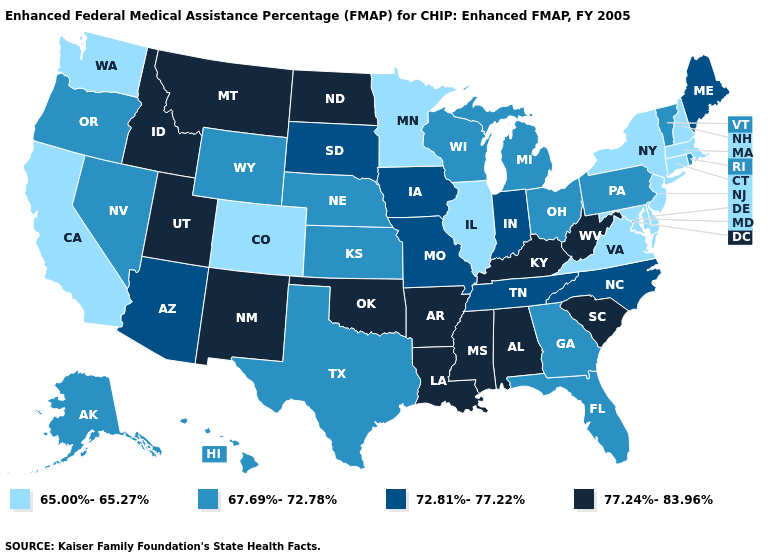Does the map have missing data?
Write a very short answer. No. What is the lowest value in the Northeast?
Short answer required. 65.00%-65.27%. Name the states that have a value in the range 65.00%-65.27%?
Short answer required. California, Colorado, Connecticut, Delaware, Illinois, Maryland, Massachusetts, Minnesota, New Hampshire, New Jersey, New York, Virginia, Washington. Name the states that have a value in the range 65.00%-65.27%?
Concise answer only. California, Colorado, Connecticut, Delaware, Illinois, Maryland, Massachusetts, Minnesota, New Hampshire, New Jersey, New York, Virginia, Washington. Does Michigan have a higher value than North Carolina?
Quick response, please. No. What is the value of Tennessee?
Answer briefly. 72.81%-77.22%. What is the highest value in the USA?
Be succinct. 77.24%-83.96%. Which states hav the highest value in the West?
Answer briefly. Idaho, Montana, New Mexico, Utah. What is the value of Massachusetts?
Short answer required. 65.00%-65.27%. Name the states that have a value in the range 77.24%-83.96%?
Quick response, please. Alabama, Arkansas, Idaho, Kentucky, Louisiana, Mississippi, Montana, New Mexico, North Dakota, Oklahoma, South Carolina, Utah, West Virginia. Name the states that have a value in the range 67.69%-72.78%?
Answer briefly. Alaska, Florida, Georgia, Hawaii, Kansas, Michigan, Nebraska, Nevada, Ohio, Oregon, Pennsylvania, Rhode Island, Texas, Vermont, Wisconsin, Wyoming. Name the states that have a value in the range 65.00%-65.27%?
Write a very short answer. California, Colorado, Connecticut, Delaware, Illinois, Maryland, Massachusetts, Minnesota, New Hampshire, New Jersey, New York, Virginia, Washington. Does the first symbol in the legend represent the smallest category?
Concise answer only. Yes. Name the states that have a value in the range 77.24%-83.96%?
Be succinct. Alabama, Arkansas, Idaho, Kentucky, Louisiana, Mississippi, Montana, New Mexico, North Dakota, Oklahoma, South Carolina, Utah, West Virginia. What is the value of Delaware?
Be succinct. 65.00%-65.27%. 